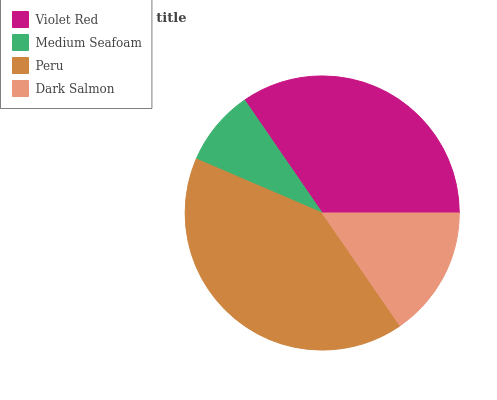Is Medium Seafoam the minimum?
Answer yes or no. Yes. Is Peru the maximum?
Answer yes or no. Yes. Is Peru the minimum?
Answer yes or no. No. Is Medium Seafoam the maximum?
Answer yes or no. No. Is Peru greater than Medium Seafoam?
Answer yes or no. Yes. Is Medium Seafoam less than Peru?
Answer yes or no. Yes. Is Medium Seafoam greater than Peru?
Answer yes or no. No. Is Peru less than Medium Seafoam?
Answer yes or no. No. Is Violet Red the high median?
Answer yes or no. Yes. Is Dark Salmon the low median?
Answer yes or no. Yes. Is Medium Seafoam the high median?
Answer yes or no. No. Is Peru the low median?
Answer yes or no. No. 